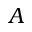Convert formula to latex. <formula><loc_0><loc_0><loc_500><loc_500>A</formula> 